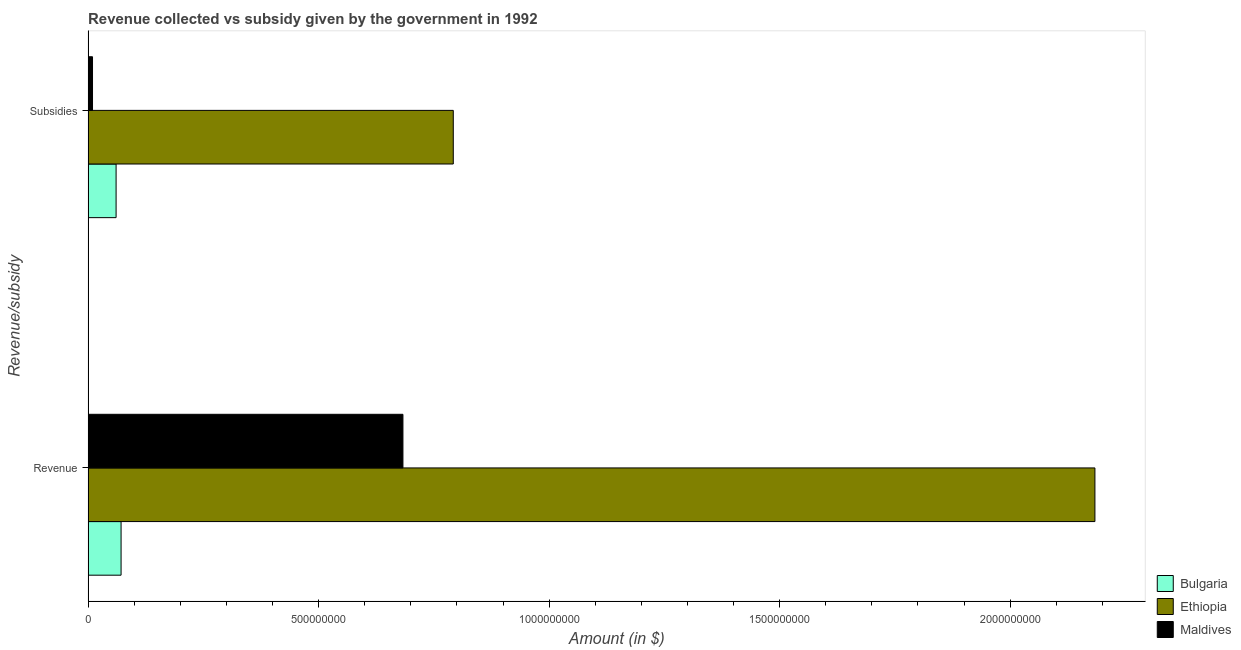How many groups of bars are there?
Keep it short and to the point. 2. Are the number of bars on each tick of the Y-axis equal?
Your response must be concise. Yes. How many bars are there on the 2nd tick from the top?
Make the answer very short. 3. What is the label of the 2nd group of bars from the top?
Your answer should be very brief. Revenue. What is the amount of revenue collected in Maldives?
Offer a terse response. 6.83e+08. Across all countries, what is the maximum amount of revenue collected?
Offer a terse response. 2.18e+09. Across all countries, what is the minimum amount of subsidies given?
Offer a terse response. 9.60e+06. In which country was the amount of revenue collected maximum?
Provide a succinct answer. Ethiopia. In which country was the amount of revenue collected minimum?
Offer a very short reply. Bulgaria. What is the total amount of revenue collected in the graph?
Make the answer very short. 2.94e+09. What is the difference between the amount of revenue collected in Maldives and that in Ethiopia?
Provide a short and direct response. -1.50e+09. What is the difference between the amount of subsidies given in Maldives and the amount of revenue collected in Ethiopia?
Provide a short and direct response. -2.17e+09. What is the average amount of revenue collected per country?
Provide a succinct answer. 9.79e+08. What is the difference between the amount of revenue collected and amount of subsidies given in Maldives?
Make the answer very short. 6.73e+08. In how many countries, is the amount of subsidies given greater than 1800000000 $?
Your answer should be very brief. 0. What is the ratio of the amount of subsidies given in Maldives to that in Bulgaria?
Your answer should be compact. 0.16. What does the 1st bar from the top in Revenue represents?
Ensure brevity in your answer.  Maldives. What does the 2nd bar from the bottom in Revenue represents?
Offer a very short reply. Ethiopia. How many bars are there?
Offer a very short reply. 6. Are all the bars in the graph horizontal?
Keep it short and to the point. Yes. Are the values on the major ticks of X-axis written in scientific E-notation?
Keep it short and to the point. No. Does the graph contain any zero values?
Ensure brevity in your answer.  No. Does the graph contain grids?
Give a very brief answer. No. How many legend labels are there?
Provide a short and direct response. 3. How are the legend labels stacked?
Provide a short and direct response. Vertical. What is the title of the graph?
Your answer should be compact. Revenue collected vs subsidy given by the government in 1992. Does "Kyrgyz Republic" appear as one of the legend labels in the graph?
Your response must be concise. No. What is the label or title of the X-axis?
Your response must be concise. Amount (in $). What is the label or title of the Y-axis?
Ensure brevity in your answer.  Revenue/subsidy. What is the Amount (in $) in Bulgaria in Revenue?
Offer a terse response. 7.15e+07. What is the Amount (in $) of Ethiopia in Revenue?
Provide a short and direct response. 2.18e+09. What is the Amount (in $) in Maldives in Revenue?
Keep it short and to the point. 6.83e+08. What is the Amount (in $) of Bulgaria in Subsidies?
Offer a very short reply. 6.07e+07. What is the Amount (in $) in Ethiopia in Subsidies?
Give a very brief answer. 7.92e+08. What is the Amount (in $) in Maldives in Subsidies?
Offer a very short reply. 9.60e+06. Across all Revenue/subsidy, what is the maximum Amount (in $) of Bulgaria?
Provide a short and direct response. 7.15e+07. Across all Revenue/subsidy, what is the maximum Amount (in $) in Ethiopia?
Give a very brief answer. 2.18e+09. Across all Revenue/subsidy, what is the maximum Amount (in $) in Maldives?
Offer a very short reply. 6.83e+08. Across all Revenue/subsidy, what is the minimum Amount (in $) of Bulgaria?
Your answer should be very brief. 6.07e+07. Across all Revenue/subsidy, what is the minimum Amount (in $) in Ethiopia?
Make the answer very short. 7.92e+08. Across all Revenue/subsidy, what is the minimum Amount (in $) of Maldives?
Offer a very short reply. 9.60e+06. What is the total Amount (in $) in Bulgaria in the graph?
Offer a very short reply. 1.32e+08. What is the total Amount (in $) of Ethiopia in the graph?
Provide a short and direct response. 2.98e+09. What is the total Amount (in $) in Maldives in the graph?
Make the answer very short. 6.92e+08. What is the difference between the Amount (in $) in Bulgaria in Revenue and that in Subsidies?
Your answer should be compact. 1.08e+07. What is the difference between the Amount (in $) of Ethiopia in Revenue and that in Subsidies?
Offer a very short reply. 1.39e+09. What is the difference between the Amount (in $) in Maldives in Revenue and that in Subsidies?
Keep it short and to the point. 6.73e+08. What is the difference between the Amount (in $) in Bulgaria in Revenue and the Amount (in $) in Ethiopia in Subsidies?
Provide a short and direct response. -7.21e+08. What is the difference between the Amount (in $) of Bulgaria in Revenue and the Amount (in $) of Maldives in Subsidies?
Your answer should be compact. 6.19e+07. What is the difference between the Amount (in $) of Ethiopia in Revenue and the Amount (in $) of Maldives in Subsidies?
Make the answer very short. 2.17e+09. What is the average Amount (in $) of Bulgaria per Revenue/subsidy?
Make the answer very short. 6.61e+07. What is the average Amount (in $) in Ethiopia per Revenue/subsidy?
Provide a succinct answer. 1.49e+09. What is the average Amount (in $) of Maldives per Revenue/subsidy?
Keep it short and to the point. 3.46e+08. What is the difference between the Amount (in $) of Bulgaria and Amount (in $) of Ethiopia in Revenue?
Ensure brevity in your answer.  -2.11e+09. What is the difference between the Amount (in $) of Bulgaria and Amount (in $) of Maldives in Revenue?
Keep it short and to the point. -6.11e+08. What is the difference between the Amount (in $) in Ethiopia and Amount (in $) in Maldives in Revenue?
Provide a succinct answer. 1.50e+09. What is the difference between the Amount (in $) of Bulgaria and Amount (in $) of Ethiopia in Subsidies?
Make the answer very short. -7.31e+08. What is the difference between the Amount (in $) in Bulgaria and Amount (in $) in Maldives in Subsidies?
Your response must be concise. 5.11e+07. What is the difference between the Amount (in $) of Ethiopia and Amount (in $) of Maldives in Subsidies?
Provide a short and direct response. 7.82e+08. What is the ratio of the Amount (in $) of Bulgaria in Revenue to that in Subsidies?
Your response must be concise. 1.18. What is the ratio of the Amount (in $) of Ethiopia in Revenue to that in Subsidies?
Your response must be concise. 2.76. What is the ratio of the Amount (in $) in Maldives in Revenue to that in Subsidies?
Offer a terse response. 71.14. What is the difference between the highest and the second highest Amount (in $) in Bulgaria?
Ensure brevity in your answer.  1.08e+07. What is the difference between the highest and the second highest Amount (in $) of Ethiopia?
Provide a succinct answer. 1.39e+09. What is the difference between the highest and the second highest Amount (in $) of Maldives?
Your answer should be very brief. 6.73e+08. What is the difference between the highest and the lowest Amount (in $) of Bulgaria?
Your answer should be compact. 1.08e+07. What is the difference between the highest and the lowest Amount (in $) in Ethiopia?
Your answer should be compact. 1.39e+09. What is the difference between the highest and the lowest Amount (in $) in Maldives?
Your response must be concise. 6.73e+08. 